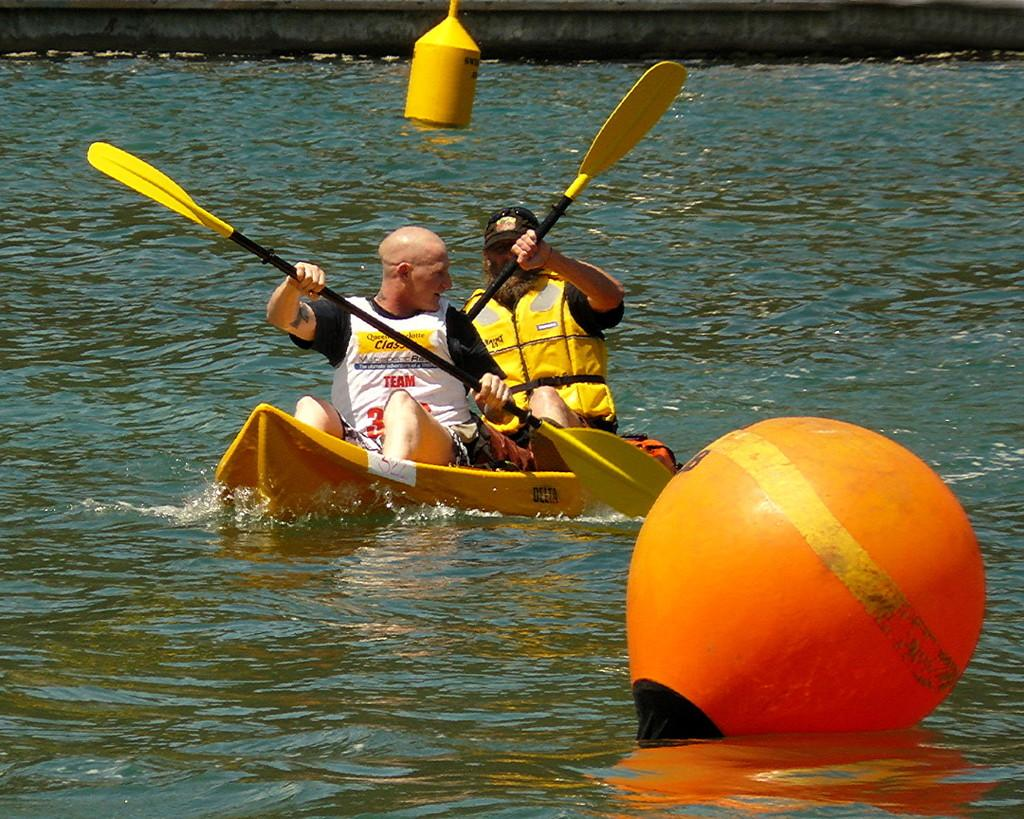What is the main feature of the image? There is a lake in the image. What activity are the two persons engaged in? The two persons are rowing a boat in the lake. What else can be seen on the water's surface? There are floating objects on the water. Where is the mailbox located in the image? There is no mailbox present in the image. What is the afterthought of the persons rowing the boat? The provided facts do not give any information about the thoughts or intentions of the persons rowing the boat, so it is impossible to determine their afterthought. 